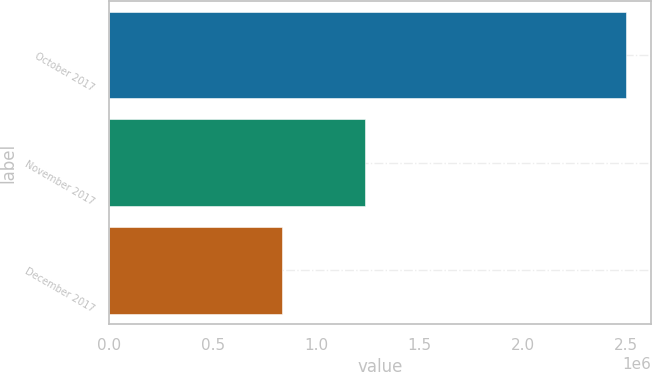Convert chart. <chart><loc_0><loc_0><loc_500><loc_500><bar_chart><fcel>October 2017<fcel>November 2017<fcel>December 2017<nl><fcel>2.49746e+06<fcel>1.23655e+06<fcel>834577<nl></chart> 